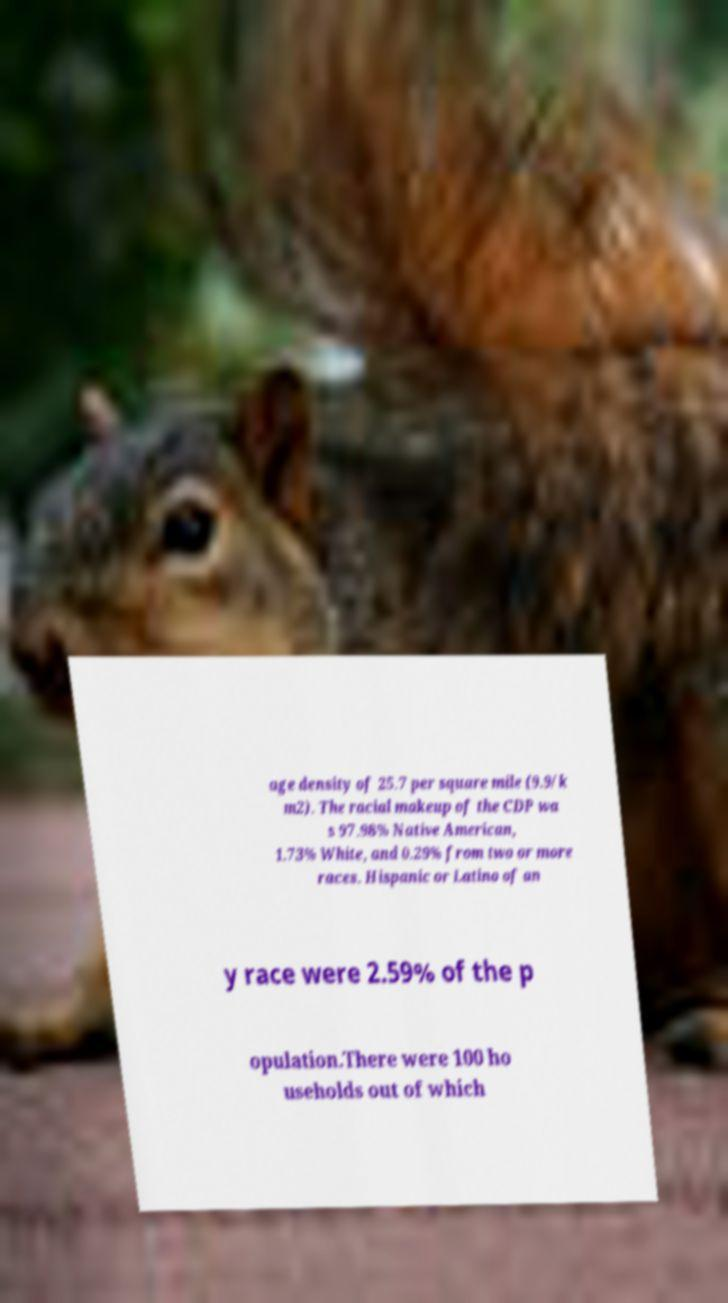Could you assist in decoding the text presented in this image and type it out clearly? age density of 25.7 per square mile (9.9/k m2). The racial makeup of the CDP wa s 97.98% Native American, 1.73% White, and 0.29% from two or more races. Hispanic or Latino of an y race were 2.59% of the p opulation.There were 100 ho useholds out of which 